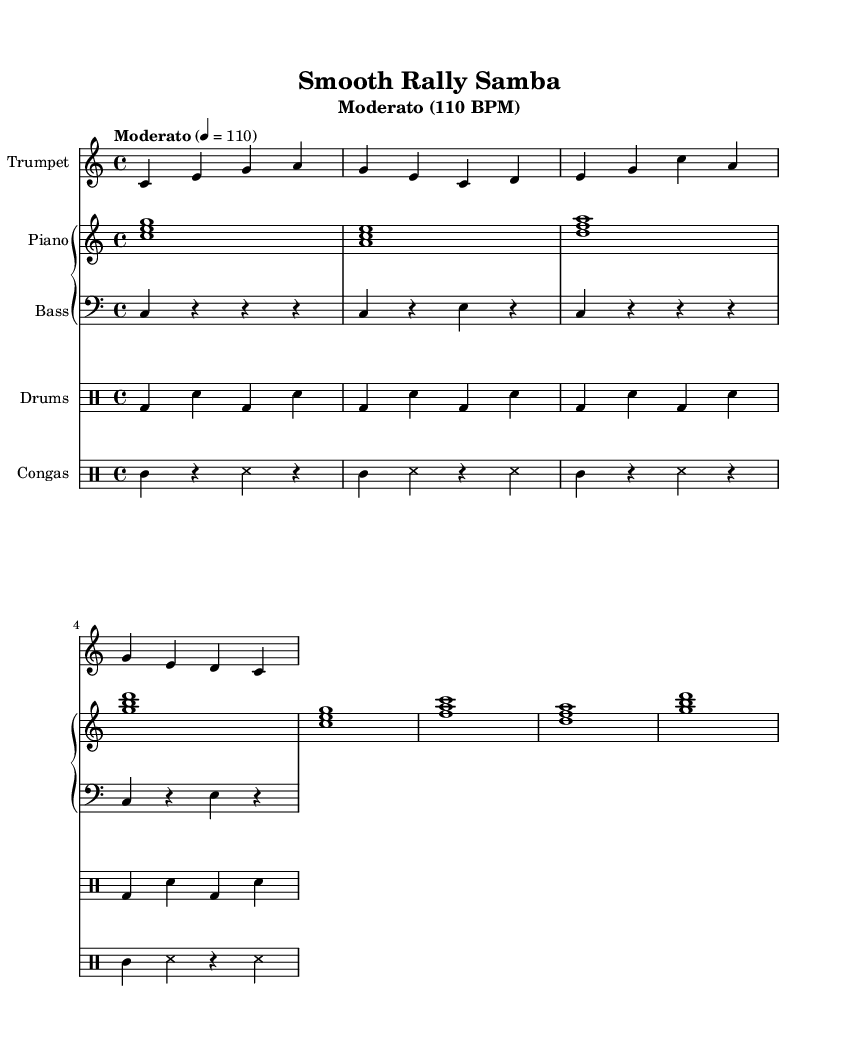What is the key signature of this music? The key signature is indicated as C major, which has no sharps or flats in the key signature. You can identify it from the global context at the beginning of the score.
Answer: C major What is the time signature of this music? The time signature appears as 4/4, which indicates four beats per measure with a quarter note receiving one beat. You can also see this clearly in the global settings of the score.
Answer: 4/4 What is the tempo marking of this music? The tempo marking in the header states "Moderato" with a tempo of 110 BPM. This means the music should be played at a moderate speed of 110 beats per minute.
Answer: Moderato, 110 BPM How many measures are present in the trumpet part? By counting the measures in the trumpet melody section, we see there are eight measures written in the section provided. Each vertical bar indicates the end of a measure.
Answer: 8 What type of rhythm section is typical for Latin jazz in this piece? The rhythm sections typical for Latin jazz in this context include a drum set and congas, which provide distinct rhythmic patterns. The notation for both drum parts can be seen on the respective staves labeled as "Drums" and "Congas."
Answer: Drum set and congas How does the bass line function within the Latin jazz structure? The bass line plays a foundational role, emphasizing the root notes of the chords, often with a pattern that uses rests effectively. In the bass part, quarter notes alternate with rests to create a syncopated rhythm that complements the other instruments.
Answer: Foundation and syncopation Which instrument plays the melody in this piece? The trumpet is designated to play the melody in this piece, as noted at the beginning of the trumpet melody section where "Trumpet" is set as the instrument name.
Answer: Trumpet 